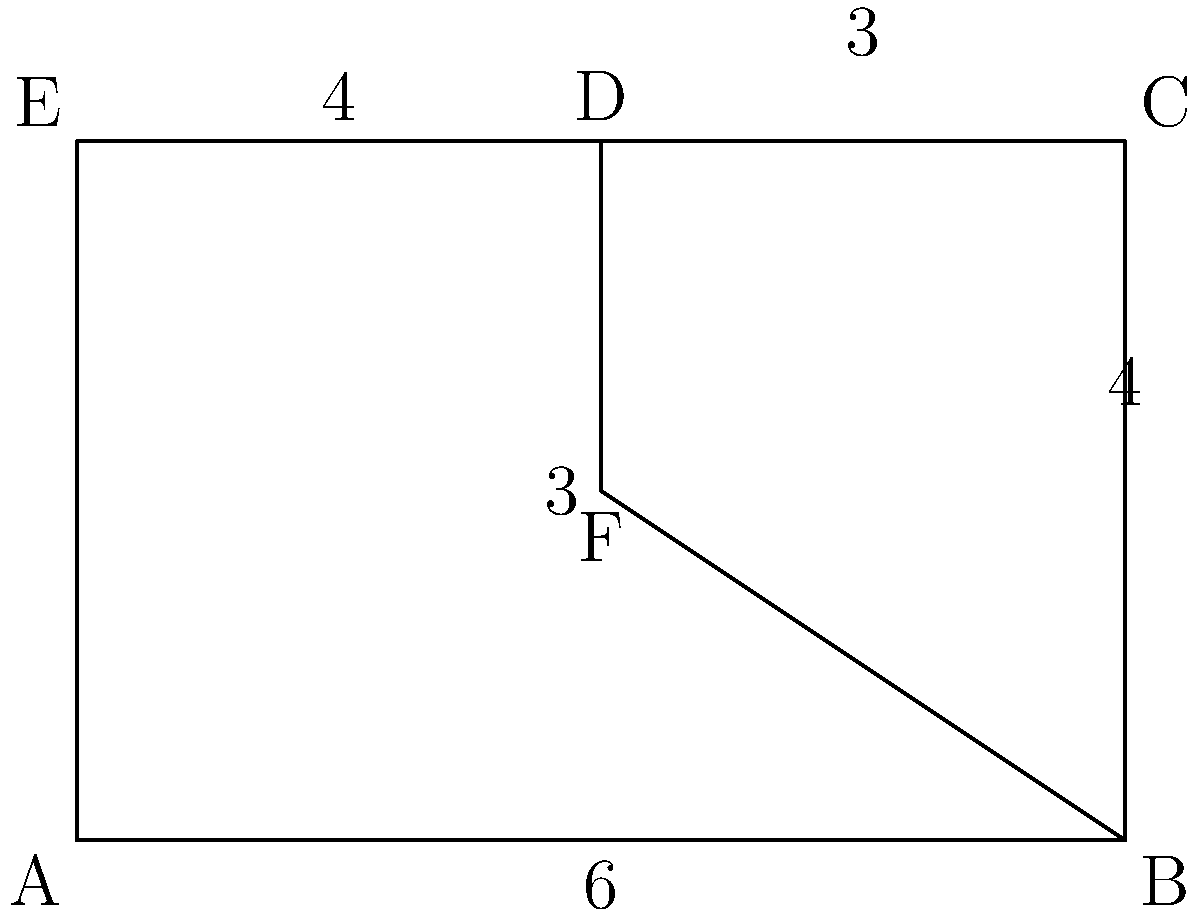As an innovative scientist exploring geometric patterns in nature, you encounter a unique leaf structure resembling the shape shown above. The leaf is composed of a rectangle (ABCDE) with a triangular section (BDF) removed. Given that AB = 6 units, BC = 4 units, and DF = 3 units, calculate the total area of this leaf-inspired shape. How might understanding such geometric patterns contribute to advancements in biomimicry and sustainable technology design in Indonesia? Let's approach this step-by-step:

1) First, we need to calculate the area of the rectangle ABCDE:
   Area of rectangle = length × width
   $A_{rectangle} = 6 \times 4 = 24$ square units

2) Next, we need to calculate the area of the triangle BDF:
   We know the base (BF = 6) and height (DF = 3) of this triangle.
   Area of triangle = $\frac{1}{2} \times$ base $\times$ height
   $A_{triangle} = \frac{1}{2} \times 6 \times 3 = 9$ square units

3) The area of the leaf-inspired shape is the difference between the area of the rectangle and the area of the triangle:
   $A_{leaf} = A_{rectangle} - A_{triangle}$
   $A_{leaf} = 24 - 9 = 15$ square units

Understanding such geometric patterns in nature can contribute significantly to advancements in biomimicry and sustainable technology design in Indonesia. This approach can lead to:

- Development of more efficient solar panel designs based on leaf structures
- Creation of water-resistant surfaces inspired by lotus leaves
- Design of stronger and lighter building materials based on honeycomb structures
- Innovation in wind turbine blade designs inspired by humpback whale fins

These applications can help address environmental challenges and promote sustainable development in Indonesia.
Answer: 15 square units 